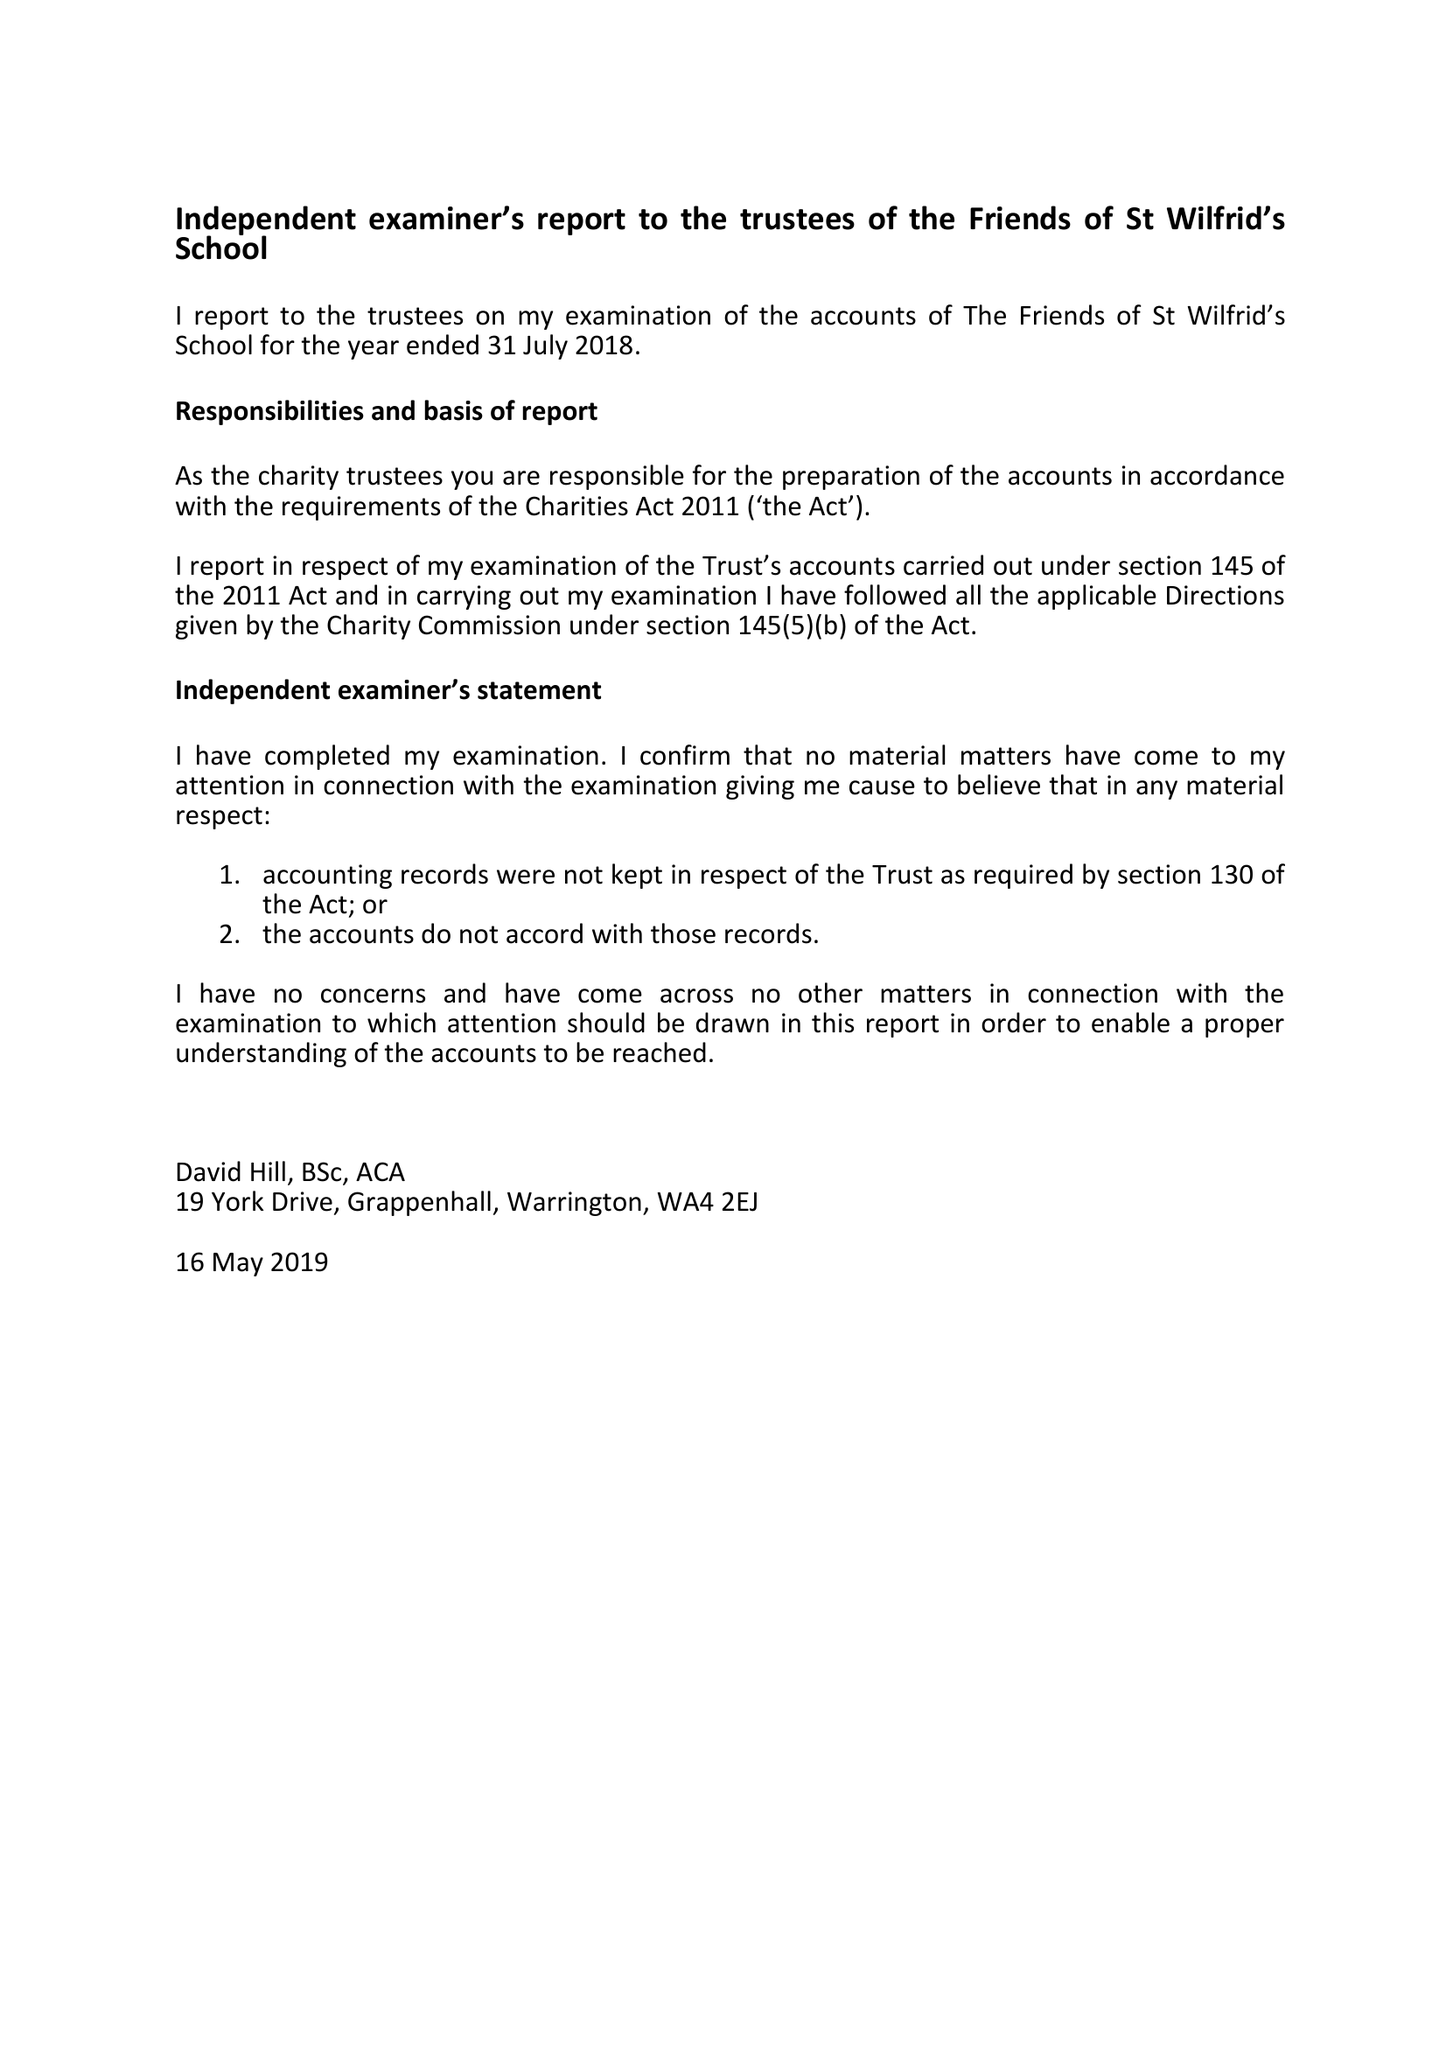What is the value for the spending_annually_in_british_pounds?
Answer the question using a single word or phrase. 10278.00 